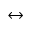Convert formula to latex. <formula><loc_0><loc_0><loc_500><loc_500>\leftrightarrow</formula> 